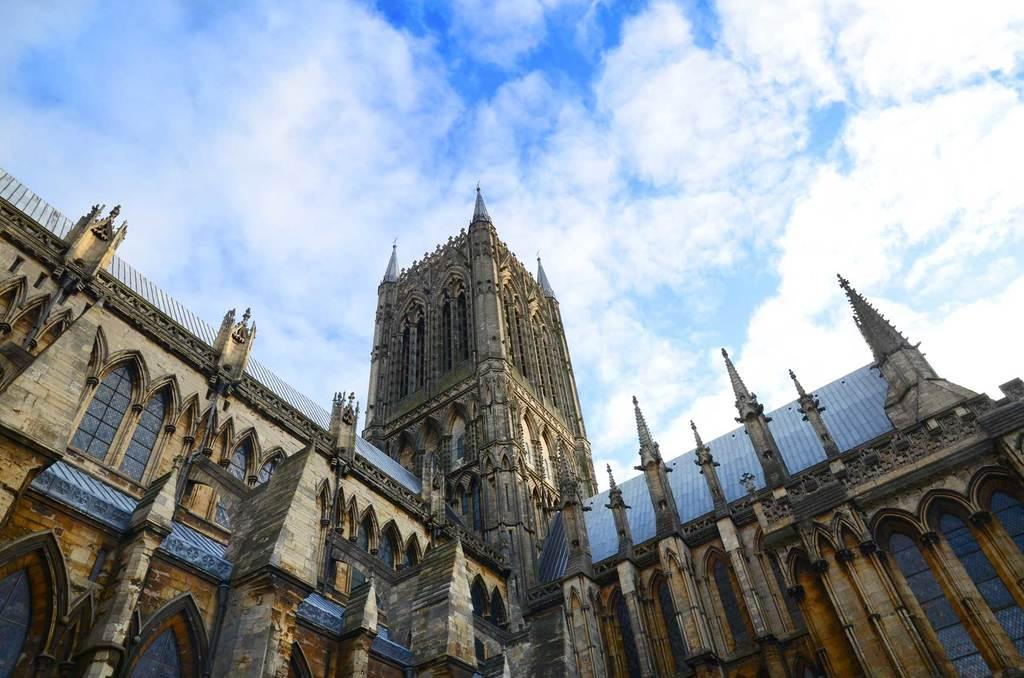What type of structure is visible at the bottom of the image? There is a building visible at the bottom of the image. What is visible in the sky at the top of the image? The sky is cloudy and visible at the top of the image. How many doors can be seen on the bridge in the image? There is no bridge present in the image, so it is not possible to determine the number of doors on a bridge. 